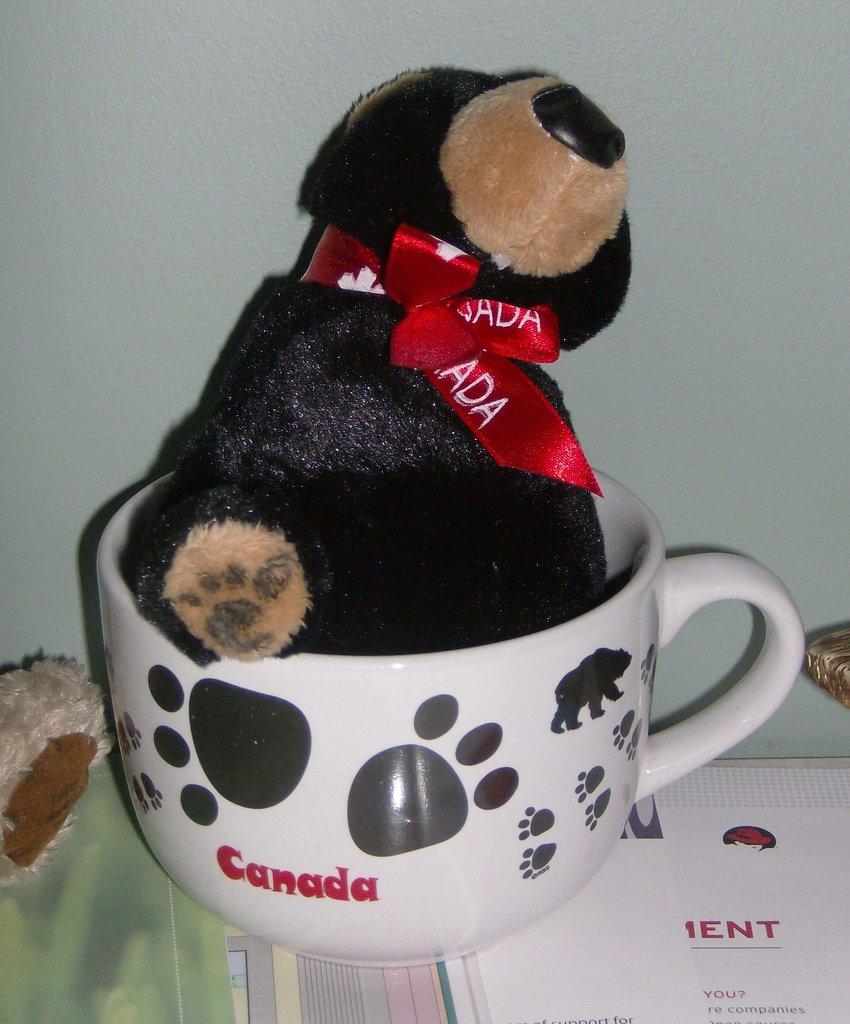What is inside the cup in the image? There is a toy in a cup in the image. Can you describe any other objects visible in the image? There are objects visible in the image, but their specific details are not mentioned in the provided facts. What can be seen in the background of the image? There is a wall in the background of the image. What type of comb is being used by the duck in the image? There is no duck or comb present in the image. What type of club is visible in the image? There is no club visible in the image. 